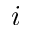<formula> <loc_0><loc_0><loc_500><loc_500>i</formula> 